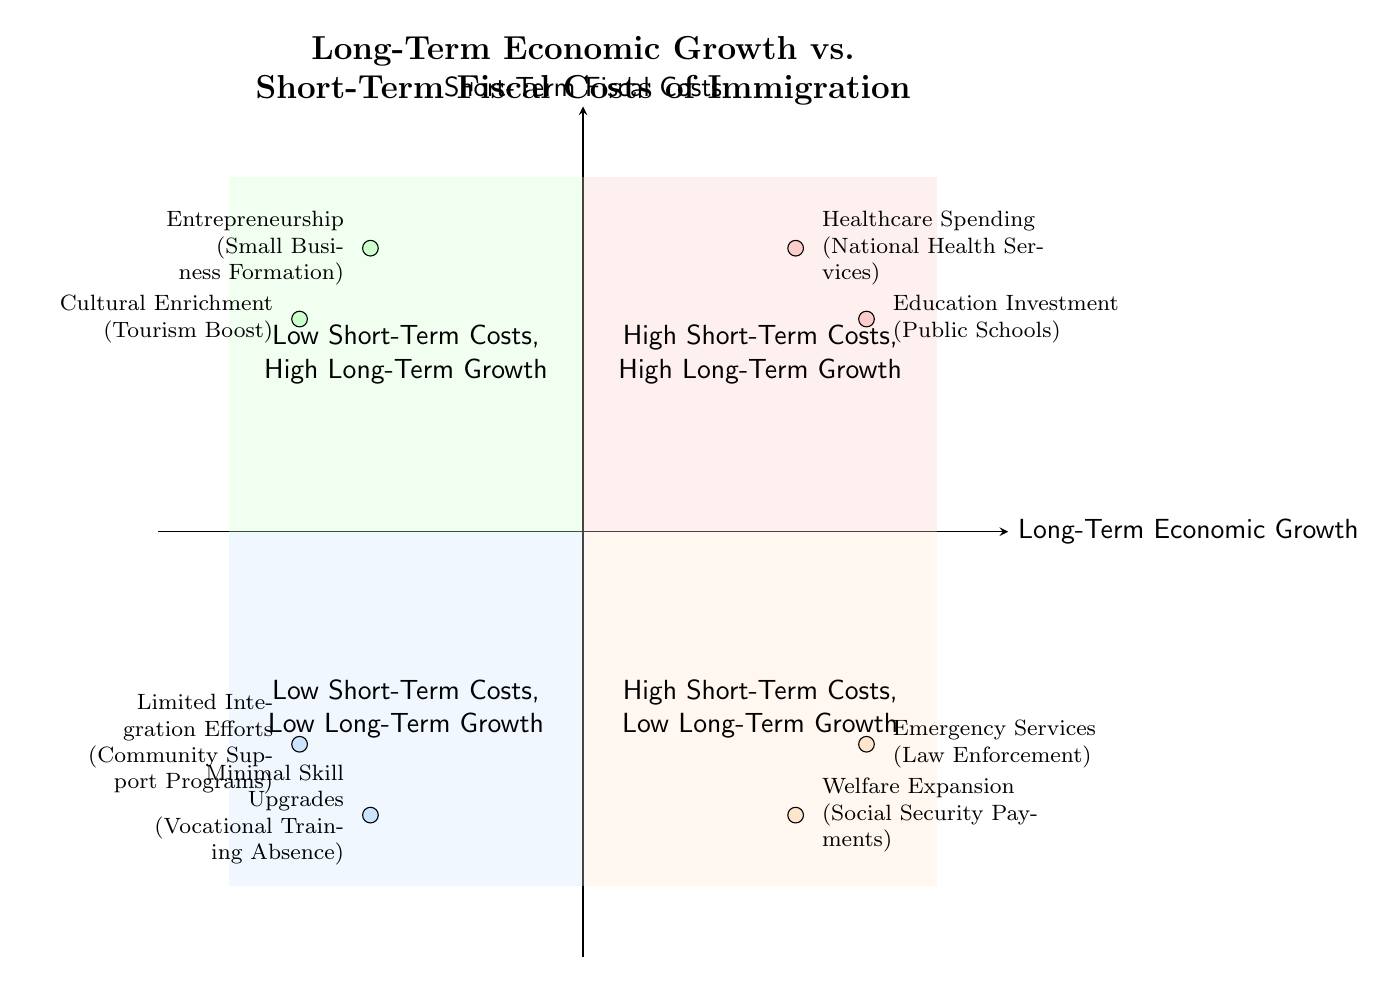What is the element representing "Healthcare Spending"? In Quadrant 1, which indicates high short-term costs and high long-term growth, "Healthcare Spending" is associated with "National Health Services."
Answer: National Health Services How many elements are in Quadrant 2? Quadrant 2 includes "Entrepreneurship" and "Cultural Enrichment," totaling two elements that indicate low short-term costs and high long-term growth.
Answer: 2 Which quadrant has "Welfare Expansion"? "Welfare Expansion" is found in Quadrant 3, which denotes high short-term costs and low long-term growth.
Answer: Quadrant 3 What type of integration efforts are represented in Quadrant 4? Quadrant 4 features "Limited Integration Efforts," linked to "Community Support Programs," representing low short-term costs and low long-term growth.
Answer: Community Support Programs Which quadrant has elements related to short-term costs but different long-term growth impacts? Quadrant 1 shows high short-term costs with high long-term growth, while Quadrant 3 has high short-term costs with low long-term growth, illustrating contrasting long-term impacts.
Answer: Quadrant 1 and Quadrant 3 What is the role of "Small Business Formation" according to the diagram? "Small Business Formation" is in Quadrant 2, representing low short-term costs and high long-term growth, emphasizing its significance in driving economic progress.
Answer: Low short-term costs, high long-term growth Which two quadrants highlight high short-term costs? Quadrants 1 and 3 both highlight high short-term costs; Quadrant 1 with high long-term growth and Quadrant 3 with low long-term growth.
Answer: Quadrant 1 and Quadrant 3 How is "Cultural Enrichment" classified in terms of short-term fiscal costs? "Cultural Enrichment," associated with "Tourism Boost," is classified in Quadrant 2, indicating low short-term fiscal costs and high long-term growth.
Answer: Low short-term costs What aspect does Quadrant 4 emphasize about skill development? Quadrant 4 emphasizes "Minimal Skill Upgrades" related to "Vocational Training Absence," reflecting low short-term costs and low long-term growth.
Answer: Minimal Skill Upgrades 